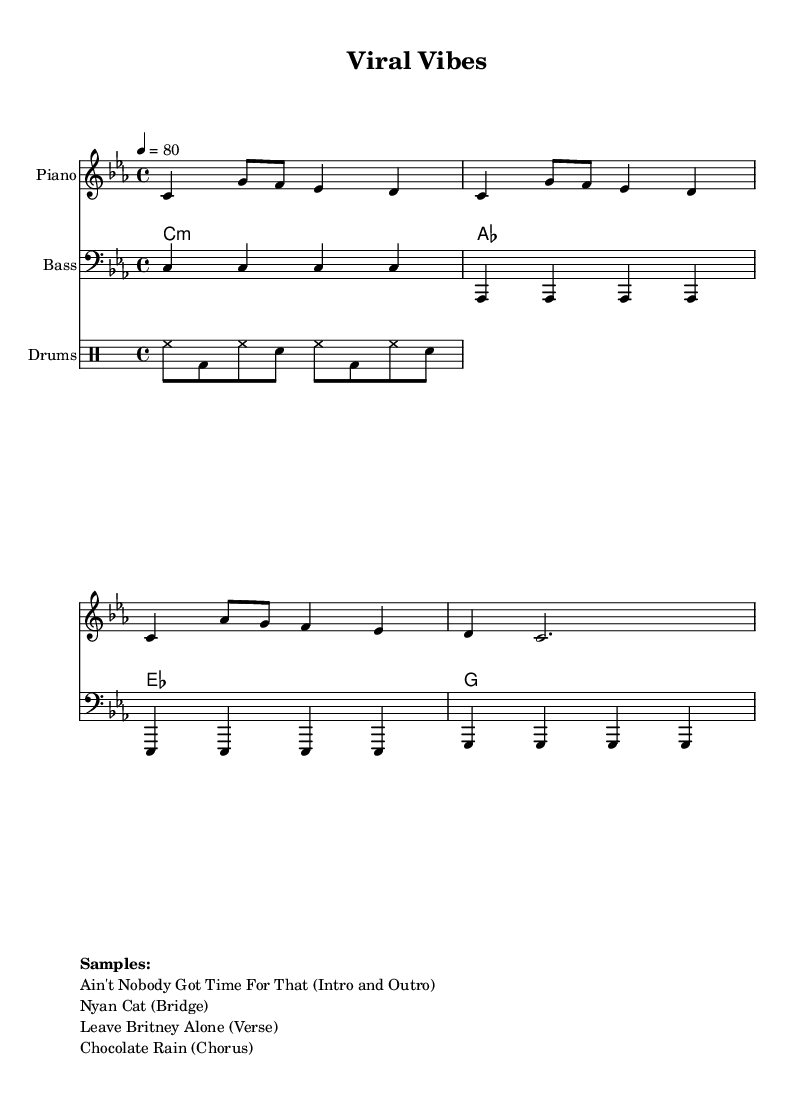What is the key signature of this music? The key signature is C minor, which has three flats: B flat, E flat, and A flat.
Answer: C minor What is the time signature of this piece? The time signature is indicated at the beginning of the score as 4/4, meaning there are four beats in a measure and the quarter note gets one beat.
Answer: 4/4 What is the tempo marking of the piece? The tempo marking is given as "4 = 80," which means that there are 80 beats per minute, with the quarter note receiving one beat per measure.
Answer: 80 How many measures are in the piano section? By counting the vertical lines that divide the staff into sections and considering the notes within, we find there are four measures in the piano section of the score.
Answer: 4 What are the samples used in this piece? The score lists four distinct samples related to viral internet videos: "Ain't Nobody Got Time For That," "Nyan Cat," "Leave Britney Alone," and "Chocolate Rain," which are used in different parts of the composition.
Answer: Ain't Nobody Got Time For That, Nyan Cat, Leave Britney Alone, Chocolate Rain Which instrument plays the root notes? The bass clef part written below the piano part indicates that the bass instrument plays the root notes, which are the foundation for the harmony in this piece.
Answer: Bass What musical genre does this composition belong to? The overall style of the piece, along with its use of samples from viral internet videos and chill beats, indicates that this composition belongs to the lo-fi hip hop genre.
Answer: Lo-fi hip hop 